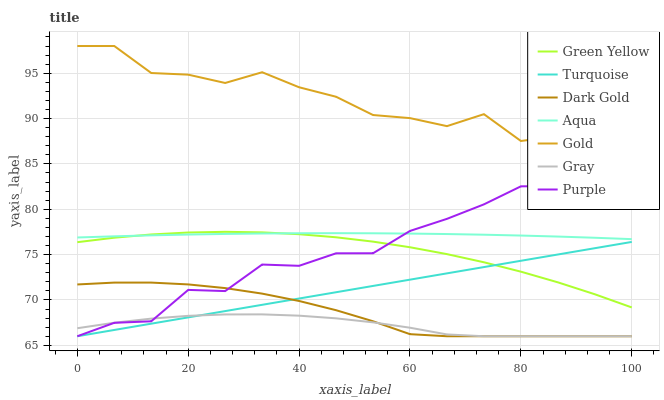Does Gray have the minimum area under the curve?
Answer yes or no. Yes. Does Gold have the maximum area under the curve?
Answer yes or no. Yes. Does Turquoise have the minimum area under the curve?
Answer yes or no. No. Does Turquoise have the maximum area under the curve?
Answer yes or no. No. Is Turquoise the smoothest?
Answer yes or no. Yes. Is Gold the roughest?
Answer yes or no. Yes. Is Gold the smoothest?
Answer yes or no. No. Is Turquoise the roughest?
Answer yes or no. No. Does Gray have the lowest value?
Answer yes or no. Yes. Does Gold have the lowest value?
Answer yes or no. No. Does Gold have the highest value?
Answer yes or no. Yes. Does Turquoise have the highest value?
Answer yes or no. No. Is Gray less than Aqua?
Answer yes or no. Yes. Is Green Yellow greater than Gray?
Answer yes or no. Yes. Does Gray intersect Purple?
Answer yes or no. Yes. Is Gray less than Purple?
Answer yes or no. No. Is Gray greater than Purple?
Answer yes or no. No. Does Gray intersect Aqua?
Answer yes or no. No. 